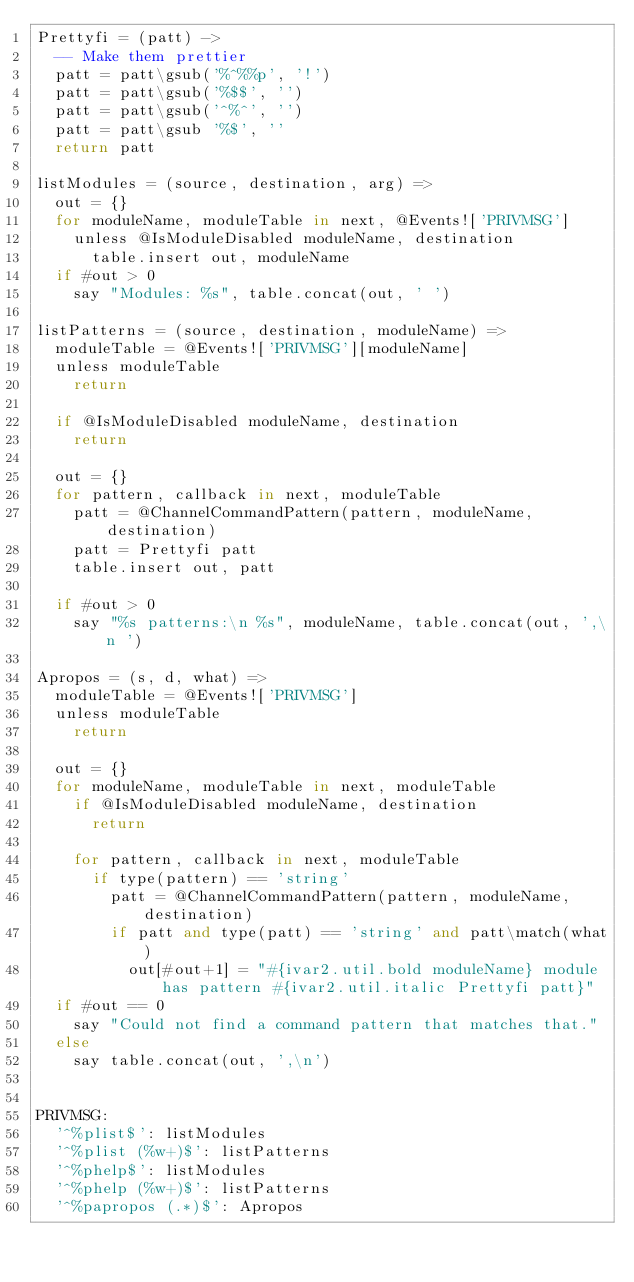<code> <loc_0><loc_0><loc_500><loc_500><_MoonScript_>Prettyfi = (patt) ->
  -- Make them prettier
  patt = patt\gsub('%^%%p', '!')
  patt = patt\gsub('%$$', '')
  patt = patt\gsub('^%^', '')
  patt = patt\gsub '%$', ''
  return patt

listModules = (source, destination, arg) =>
  out = {}
  for moduleName, moduleTable in next, @Events!['PRIVMSG']
    unless @IsModuleDisabled moduleName, destination
      table.insert out, moduleName
  if #out > 0
    say "Modules: %s", table.concat(out, ' ')

listPatterns = (source, destination, moduleName) =>
  moduleTable = @Events!['PRIVMSG'][moduleName]
  unless moduleTable
    return

  if @IsModuleDisabled moduleName, destination
    return

  out = {}
  for pattern, callback in next, moduleTable
    patt = @ChannelCommandPattern(pattern, moduleName, destination)
    patt = Prettyfi patt
    table.insert out, patt

  if #out > 0
    say "%s patterns:\n %s", moduleName, table.concat(out, ',\n ')

Apropos = (s, d, what) =>
  moduleTable = @Events!['PRIVMSG']
  unless moduleTable
    return

  out = {}
  for moduleName, moduleTable in next, moduleTable
    if @IsModuleDisabled moduleName, destination
      return

    for pattern, callback in next, moduleTable
      if type(pattern) == 'string'
        patt = @ChannelCommandPattern(pattern, moduleName, destination)
        if patt and type(patt) == 'string' and patt\match(what)
          out[#out+1] = "#{ivar2.util.bold moduleName} module has pattern #{ivar2.util.italic Prettyfi patt}"
  if #out == 0
    say "Could not find a command pattern that matches that."
  else
    say table.concat(out, ',\n')


PRIVMSG:
  '^%plist$': listModules
  '^%plist (%w+)$': listPatterns
  '^%phelp$': listModules
  '^%phelp (%w+)$': listPatterns
  '^%papropos (.*)$': Apropos
</code> 